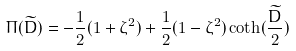Convert formula to latex. <formula><loc_0><loc_0><loc_500><loc_500>\Pi ( \widetilde { D } ) = - \frac { 1 } { 2 } ( 1 + \zeta ^ { 2 } ) + \frac { 1 } { 2 } ( 1 - \zeta ^ { 2 } ) \coth ( \frac { \widetilde { D } } { 2 } )</formula> 